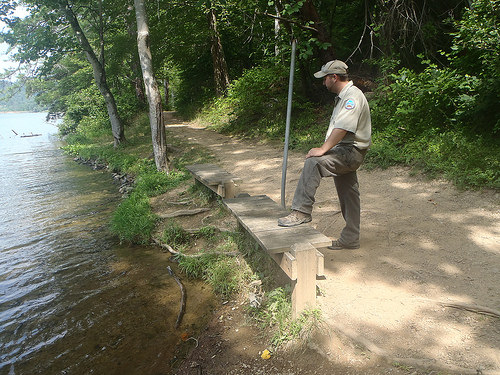<image>
Is the man in front of the water? Yes. The man is positioned in front of the water, appearing closer to the camera viewpoint. 